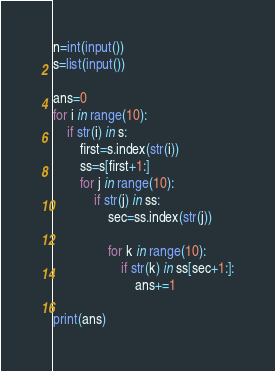<code> <loc_0><loc_0><loc_500><loc_500><_Python_>n=int(input())
s=list(input())

ans=0
for i in range(10):
    if str(i) in s:
        first=s.index(str(i))
        ss=s[first+1:]
        for j in range(10):
            if str(j) in ss:
                sec=ss.index(str(j))

                for k in range(10):
                    if str(k) in ss[sec+1:]:
                        ans+=1

print(ans)</code> 